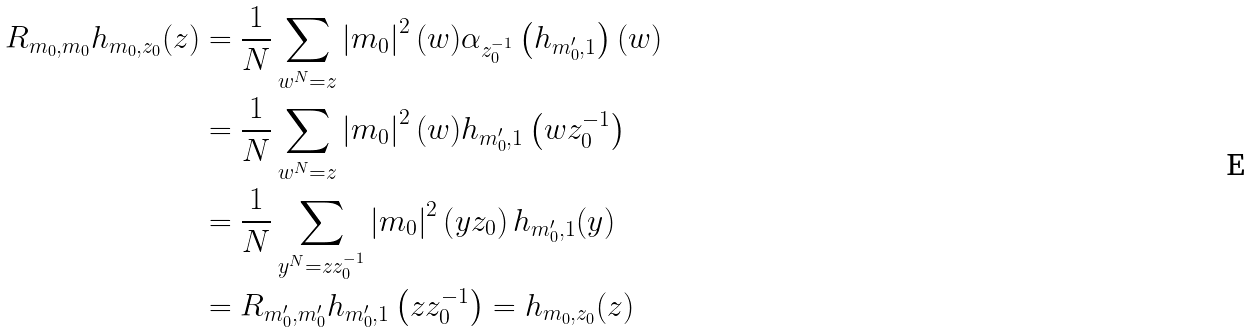Convert formula to latex. <formula><loc_0><loc_0><loc_500><loc_500>R _ { m _ { 0 } , m _ { 0 } } h _ { m _ { 0 } , z _ { 0 } } ( z ) & = \frac { 1 } { N } \sum _ { w ^ { N } = z } \left | m _ { 0 } \right | ^ { 2 } ( w ) \alpha _ { z _ { 0 } ^ { - 1 } } \left ( h _ { m _ { 0 } ^ { \prime } , 1 } \right ) ( w ) \\ & = \frac { 1 } { N } \sum _ { w ^ { N } = z } \left | m _ { 0 } \right | ^ { 2 } ( w ) h _ { m _ { 0 } ^ { \prime } , 1 } \left ( w z _ { 0 } ^ { - 1 } \right ) \\ & = \frac { 1 } { N } \sum _ { y ^ { N } = z z _ { 0 } ^ { - 1 } } \left | m _ { 0 } \right | ^ { 2 } \left ( y z _ { 0 } \right ) h _ { m _ { 0 } ^ { \prime } , 1 } ( y ) \\ & = R _ { m _ { 0 } ^ { \prime } , m _ { 0 } ^ { \prime } } h _ { m _ { 0 } ^ { \prime } , 1 } \left ( z z _ { 0 } ^ { - 1 } \right ) = h _ { m _ { 0 } , z _ { 0 } } ( z )</formula> 